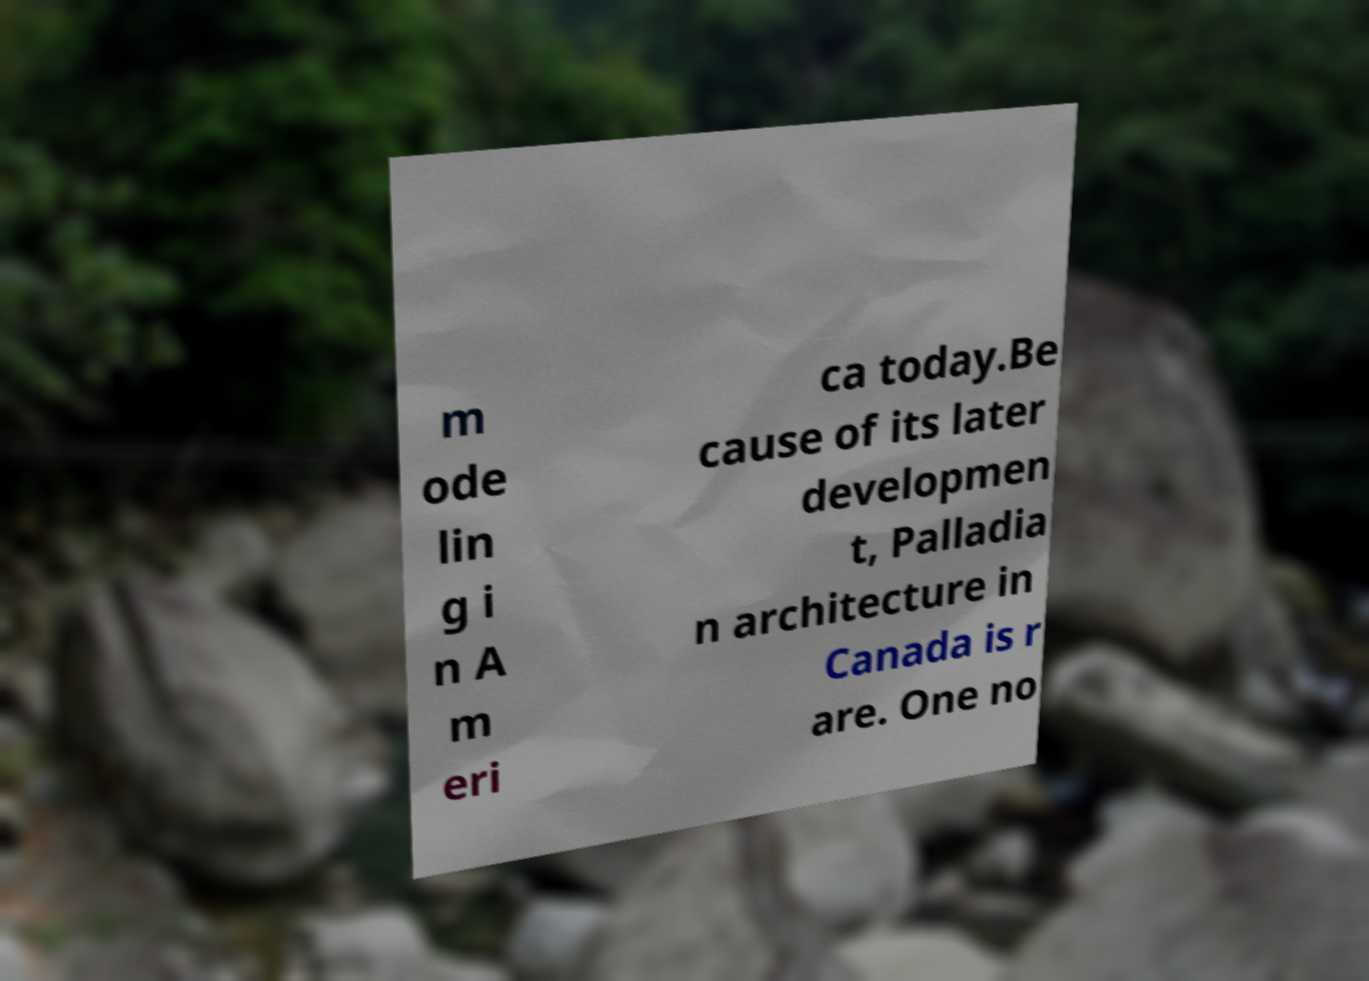What messages or text are displayed in this image? I need them in a readable, typed format. m ode lin g i n A m eri ca today.Be cause of its later developmen t, Palladia n architecture in Canada is r are. One no 